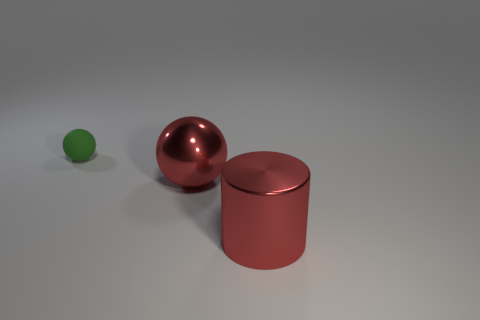Add 1 brown objects. How many objects exist? 4 Subtract all cylinders. How many objects are left? 2 Subtract 0 red blocks. How many objects are left? 3 Subtract all matte objects. Subtract all tiny red matte balls. How many objects are left? 2 Add 1 red things. How many red things are left? 3 Add 1 red shiny balls. How many red shiny balls exist? 2 